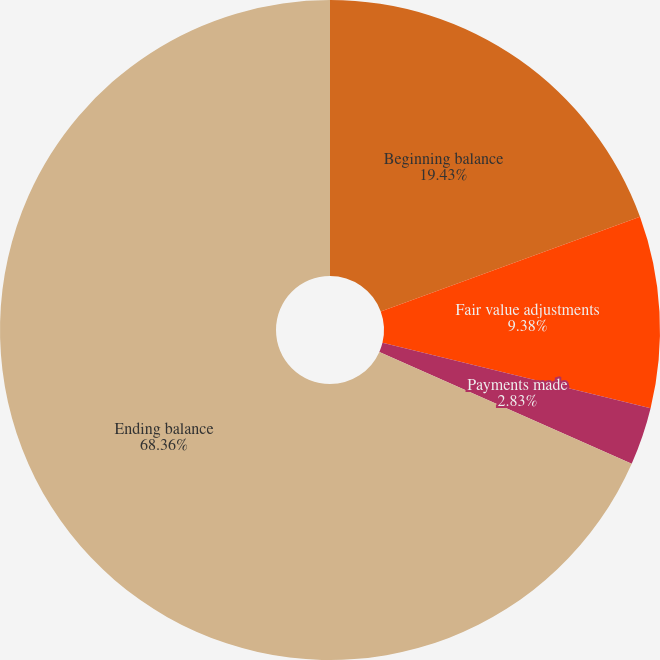Convert chart to OTSL. <chart><loc_0><loc_0><loc_500><loc_500><pie_chart><fcel>Beginning balance<fcel>Fair value adjustments<fcel>Payments made<fcel>Ending balance<nl><fcel>19.43%<fcel>9.38%<fcel>2.83%<fcel>68.36%<nl></chart> 